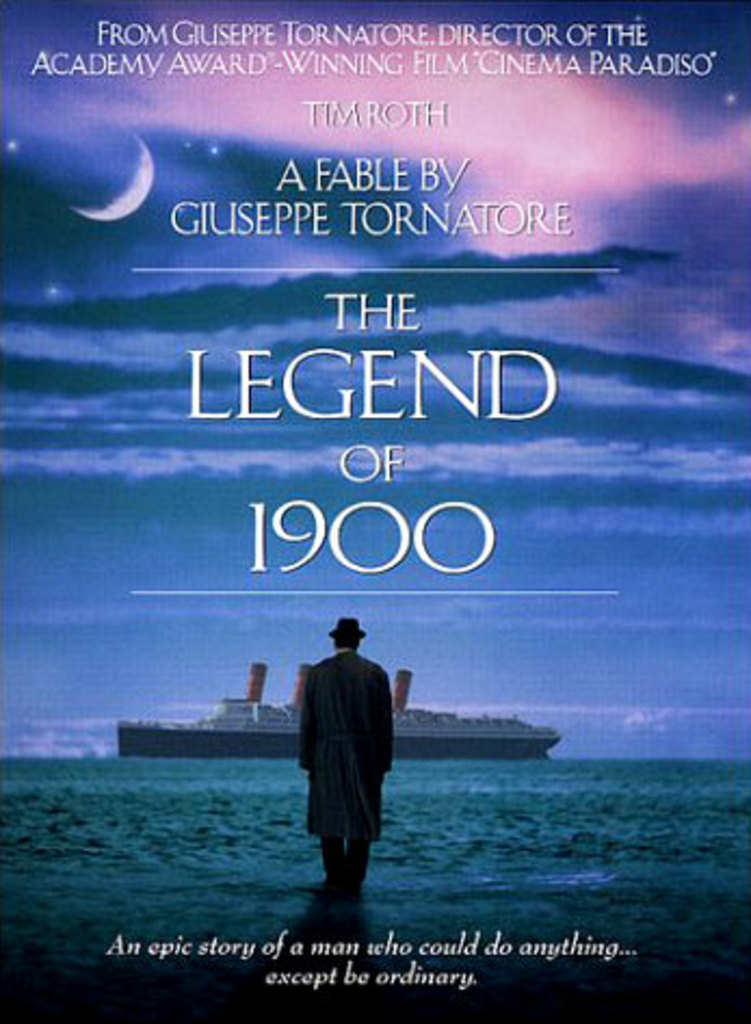How does the poster's design contribute to the mood or tone of the implied story? The use of deep blues and the image of the solitary figure looking out to sea imbues the poster with a sense of melancholy and introspection. The text layout and the luminescence of the moon add an element of mystique and wonder, effectively setting up the viewer for a story that is both epic and deeply personal. 